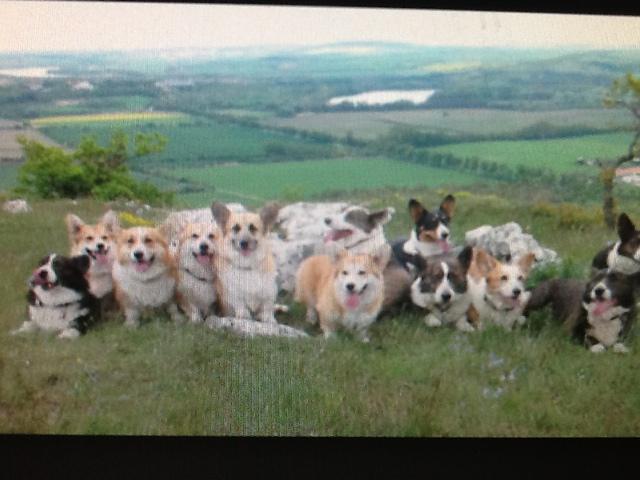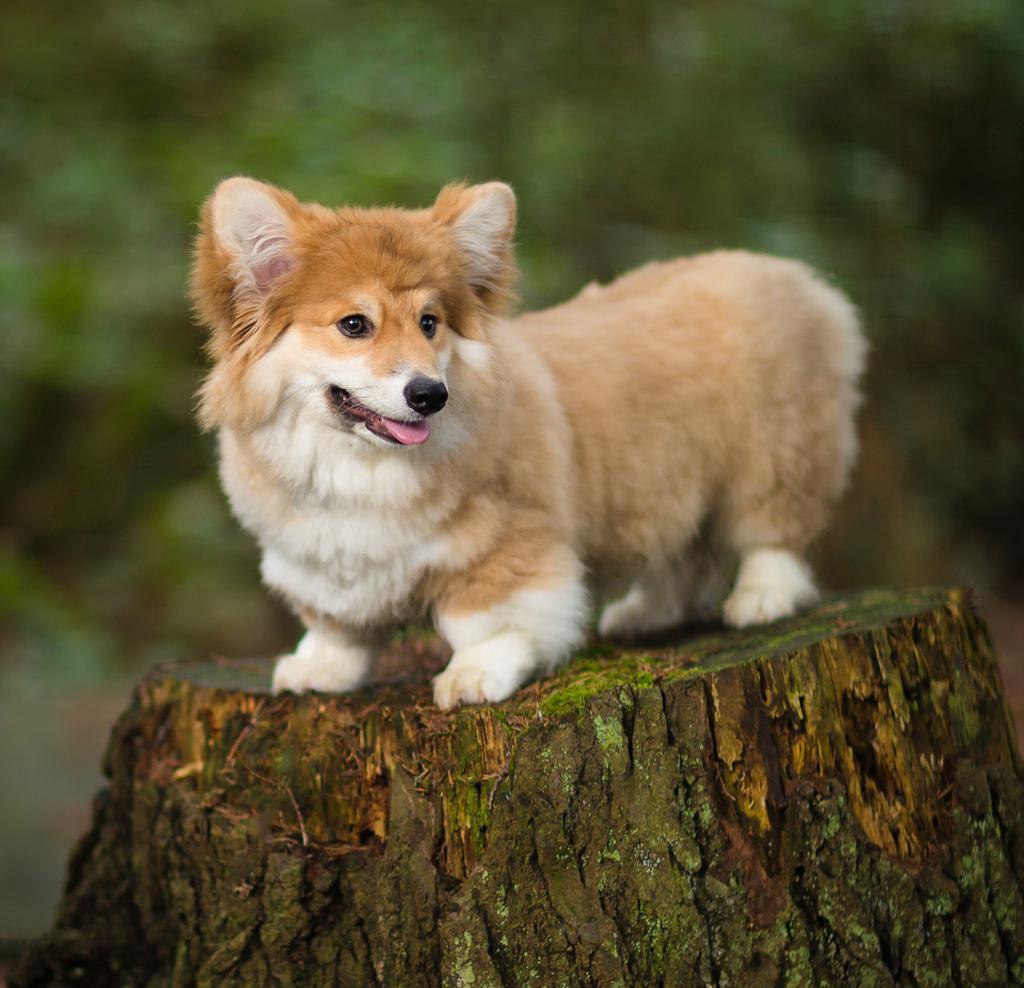The first image is the image on the left, the second image is the image on the right. Analyze the images presented: Is the assertion "One image features a horizontal row of at least four corgis on the grass, and the other image includes at least one corgi on an elevated spot." valid? Answer yes or no. Yes. The first image is the image on the left, the second image is the image on the right. Analyze the images presented: Is the assertion "The left image contains no more than two corgi dogs." valid? Answer yes or no. No. 